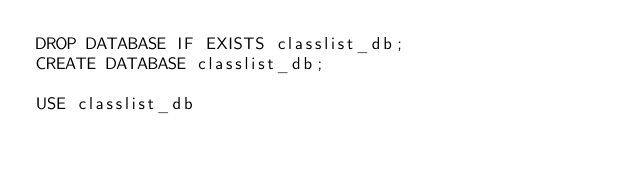<code> <loc_0><loc_0><loc_500><loc_500><_SQL_>DROP DATABASE IF EXISTS classlist_db;
CREATE DATABASE classlist_db;

USE classlist_db</code> 